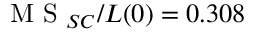<formula> <loc_0><loc_0><loc_500><loc_500>M S _ { S C } / L ( 0 ) = 0 . 3 0 8</formula> 